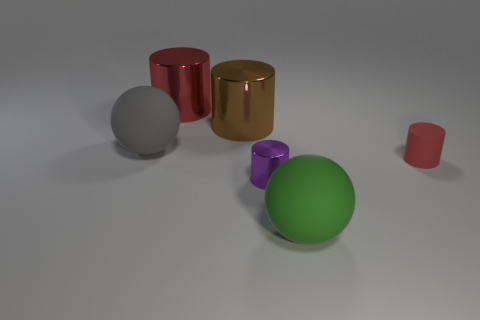Subtract all brown metal cylinders. How many cylinders are left? 3 Subtract 1 cylinders. How many cylinders are left? 3 Subtract all balls. How many objects are left? 4 Add 4 tiny cyan matte cubes. How many objects exist? 10 Subtract all yellow cylinders. Subtract all blue cubes. How many cylinders are left? 4 Subtract all large brown things. Subtract all small matte cylinders. How many objects are left? 4 Add 3 gray rubber things. How many gray rubber things are left? 4 Add 2 tiny yellow spheres. How many tiny yellow spheres exist? 2 Subtract 2 red cylinders. How many objects are left? 4 